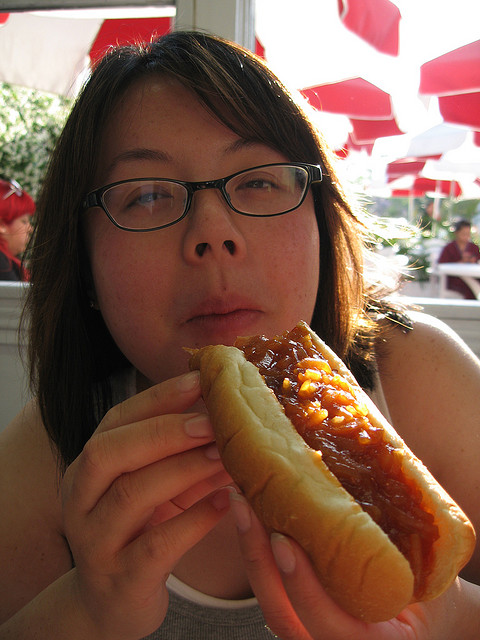What is the mood conveyed by the person in the photo? The person has a neutral expression and is focused on the act of eating, which doesn't give a clear indication of their mood, but the context of enjoying a simple pleasure like eating a hot dog may suggest a casual, contented moment. 